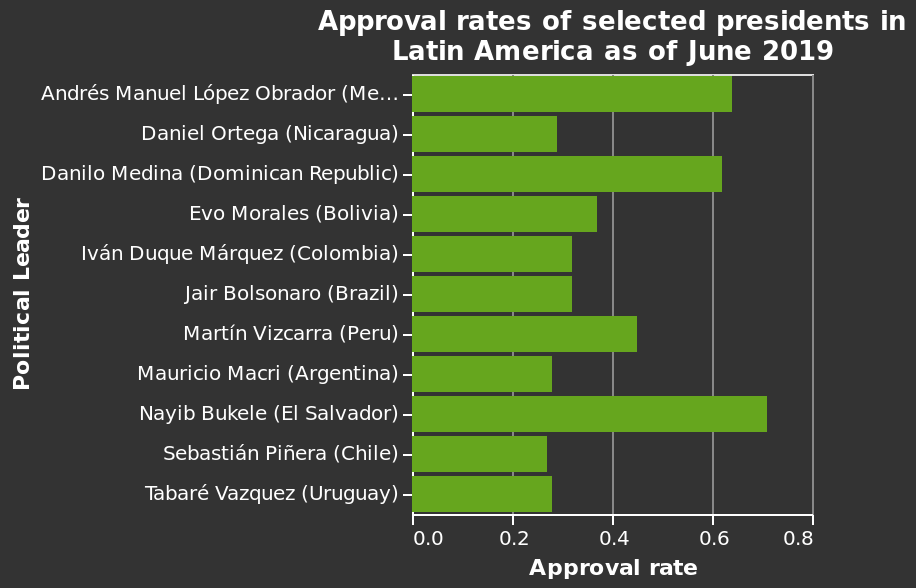<image>
Who had the highest approval rate?  Nayib Bukele had the highest approval rate. please enumerates aspects of the construction of the chart This is a bar diagram named Approval rates of selected presidents in Latin America as of June 2019. The y-axis shows Political Leader with categorical scale with Andrés Manuel López Obrador (Mexico) on one end and Tabaré Vazquez (Uruguay) at the other while the x-axis shows Approval rate on linear scale of range 0.0 to 0.8. What is the range of the x-axis? The range of the x-axis is from 0.0 to 0.8. 